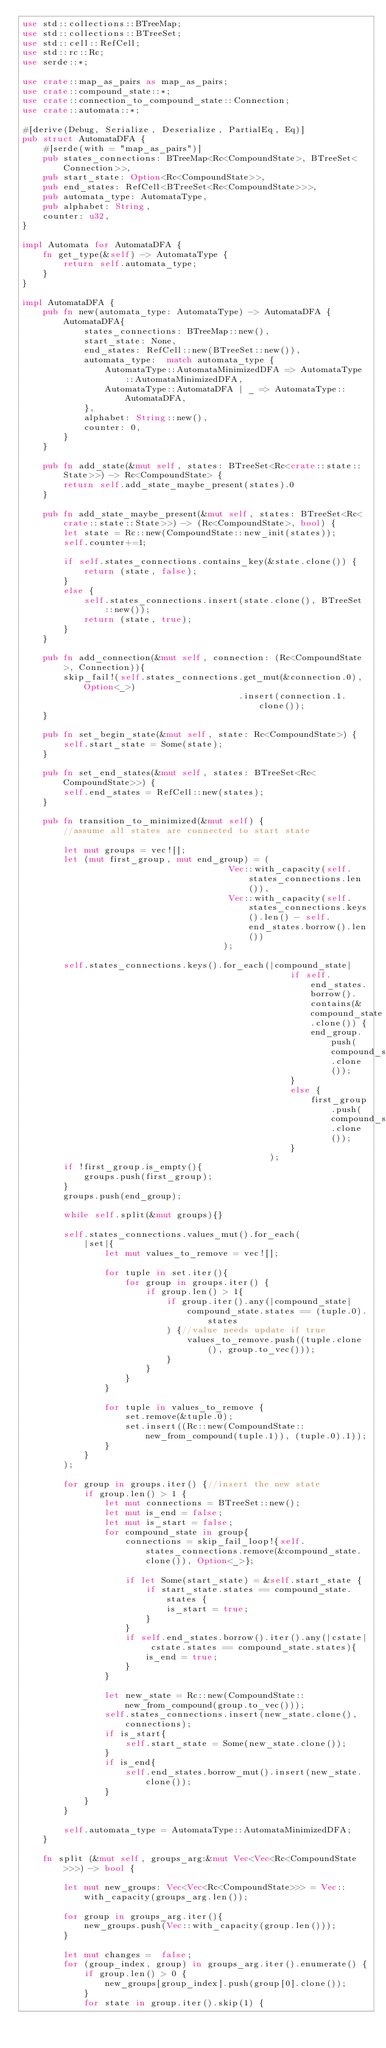Convert code to text. <code><loc_0><loc_0><loc_500><loc_500><_Rust_>use std::collections::BTreeMap;
use std::collections::BTreeSet;
use std::cell::RefCell;
use std::rc::Rc;
use serde::*;

use crate::map_as_pairs as map_as_pairs;
use crate::compound_state::*;
use crate::connection_to_compound_state::Connection;
use crate::automata::*;

#[derive(Debug, Serialize, Deserialize, PartialEq, Eq)]
pub struct AutomataDFA {
    #[serde(with = "map_as_pairs")]
    pub states_connections: BTreeMap<Rc<CompoundState>, BTreeSet<Connection>>,
    pub start_state: Option<Rc<CompoundState>>,
    pub end_states: RefCell<BTreeSet<Rc<CompoundState>>>,
    pub automata_type: AutomataType,
    pub alphabet: String,
    counter: u32,
}

impl Automata for AutomataDFA {
    fn get_type(&self) -> AutomataType {
        return self.automata_type;
    }
}

impl AutomataDFA {
    pub fn new(automata_type: AutomataType) -> AutomataDFA {
        AutomataDFA{
            states_connections: BTreeMap::new(),
            start_state: None,
            end_states: RefCell::new(BTreeSet::new()),
            automata_type:  match automata_type {
                AutomataType::AutomataMinimizedDFA => AutomataType::AutomataMinimizedDFA,
                AutomataType::AutomataDFA | _ => AutomataType::AutomataDFA,
            },
            alphabet: String::new(),
            counter: 0,
        }
    }

    pub fn add_state(&mut self, states: BTreeSet<Rc<crate::state::State>>) -> Rc<CompoundState> {
        return self.add_state_maybe_present(states).0
    }

    pub fn add_state_maybe_present(&mut self, states: BTreeSet<Rc<crate::state::State>>) -> (Rc<CompoundState>, bool) {
        let state = Rc::new(CompoundState::new_init(states));
        self.counter+=1;

        if self.states_connections.contains_key(&state.clone()) {
            return (state, false);
        }
        else {
            self.states_connections.insert(state.clone(), BTreeSet::new());
            return (state, true);
        }
    }

    pub fn add_connection(&mut self, connection: (Rc<CompoundState>, Connection)){
        skip_fail!(self.states_connections.get_mut(&connection.0), Option<_>)
                                          .insert(connection.1.clone());    
    }

    pub fn set_begin_state(&mut self, state: Rc<CompoundState>) {
        self.start_state = Some(state);
    }

    pub fn set_end_states(&mut self, states: BTreeSet<Rc<CompoundState>>) {
        self.end_states = RefCell::new(states);
    }

    pub fn transition_to_minimized(&mut self) {
        //assume all states are connected to start state

        let mut groups = vec![];
        let (mut first_group, mut end_group) = (
                                        Vec::with_capacity(self.states_connections.len()), 
                                        Vec::with_capacity(self.states_connections.keys().len() - self.end_states.borrow().len())
                                       );
         
        self.states_connections.keys().for_each(|compound_state|
                                                    if self.end_states.borrow().contains(&compound_state.clone()) {
                                                        end_group.push(compound_state.clone());
                                                    }
                                                    else {
                                                        first_group.push(compound_state.clone());
                                                    }
                                                );
        if !first_group.is_empty(){                                     
            groups.push(first_group);
        }
        groups.push(end_group);

        while self.split(&mut groups){}

        self.states_connections.values_mut().for_each(
            |set|{
                let mut values_to_remove = vec![];

                for tuple in set.iter(){
                    for group in groups.iter() {
                        if group.len() > 1{
                            if group.iter().any(|compound_state| 
                                compound_state.states == (tuple.0).states 
                            ) {//value needs update if true
                                values_to_remove.push((tuple.clone(), group.to_vec()));
                            }
                        }
                    }
                }

                for tuple in values_to_remove {
                    set.remove(&tuple.0);
                    set.insert((Rc::new(CompoundState::new_from_compound(tuple.1)), (tuple.0).1));
                }
            }
        );

        for group in groups.iter() {//insert the new state
            if group.len() > 1 {
                let mut connections = BTreeSet::new();
                let mut is_end = false;
                let mut is_start = false;
                for compound_state in group{
                    connections = skip_fail_loop!{self.states_connections.remove(&compound_state.clone()), Option<_>};      
                    
                    if let Some(start_state) = &self.start_state { 
                        if start_state.states == compound_state.states {
                            is_start = true;
                        }
                    }
                    if self.end_states.borrow().iter().any(|cstate| cstate.states == compound_state.states){
                        is_end = true;
                    } 
                }

                let new_state = Rc::new(CompoundState::new_from_compound(group.to_vec()));
                self.states_connections.insert(new_state.clone(), connections);
                if is_start{
                    self.start_state = Some(new_state.clone());
                }
                if is_end{
                    self.end_states.borrow_mut().insert(new_state.clone());
                }
            }
        }

        self.automata_type = AutomataType::AutomataMinimizedDFA;
    }

    fn split (&mut self, groups_arg:&mut Vec<Vec<Rc<CompoundState>>>) -> bool {
       
        let mut new_groups: Vec<Vec<Rc<CompoundState>>> = Vec::with_capacity(groups_arg.len());

        for group in groups_arg.iter(){
            new_groups.push(Vec::with_capacity(group.len()));
        }

        let mut changes =  false;
        for (group_index, group) in groups_arg.iter().enumerate() {    
            if group.len() > 0 {
                new_groups[group_index].push(group[0].clone());
            }
            for state in group.iter().skip(1) {</code> 